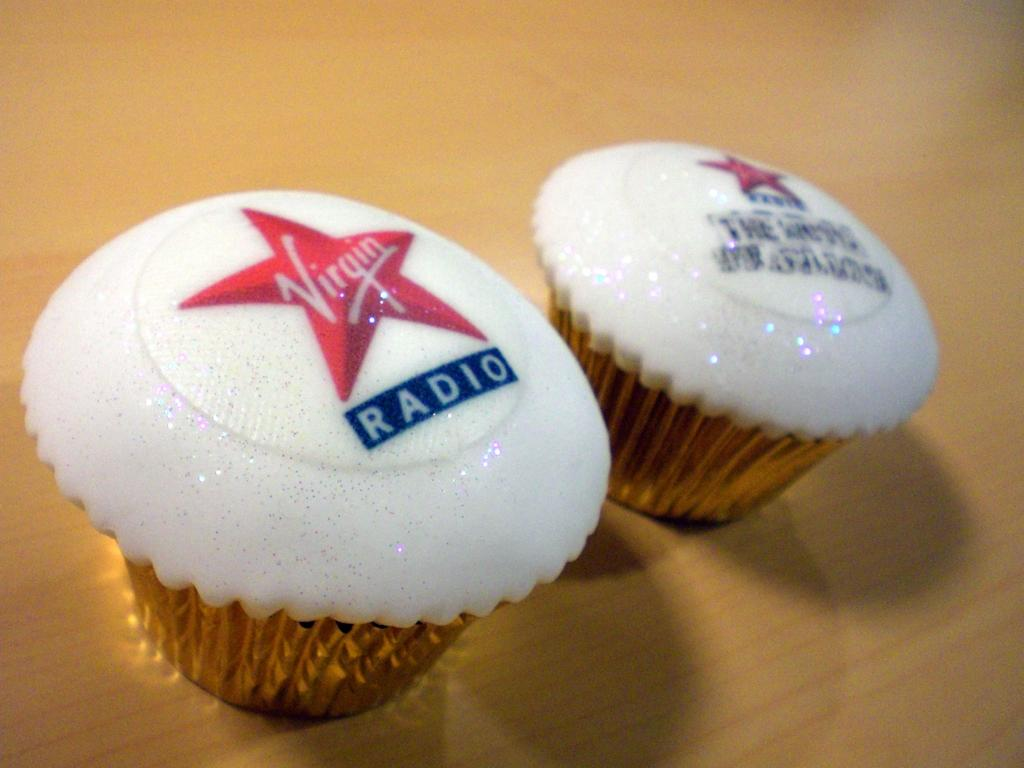What type of dessert is featured in the image? There are cupcakes in the image. What decorations are on the cupcakes? There are red color stars on the cupcakes. Is there any text or writing on the cupcakes? Yes, something is written on the cupcakes. What is the color of the surface on which the cupcakes are placed? The cupcakes are on a brown color surface. What is the governor discussing with the baker about the growth of the cupcakes in the image? There is no governor, discussion, or growth of cupcakes present in the image. The image only features cupcakes with red stars and writing on them, placed on a brown surface. 